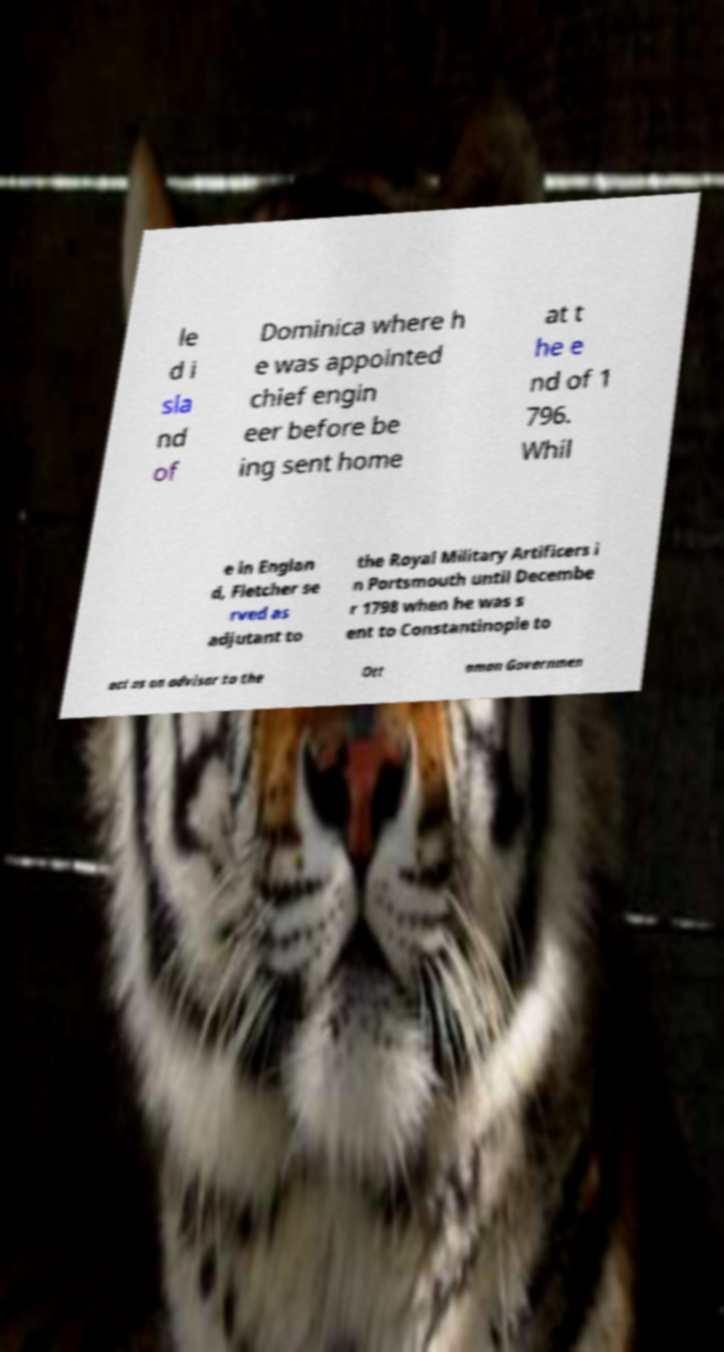Can you accurately transcribe the text from the provided image for me? le d i sla nd of Dominica where h e was appointed chief engin eer before be ing sent home at t he e nd of 1 796. Whil e in Englan d, Fletcher se rved as adjutant to the Royal Military Artificers i n Portsmouth until Decembe r 1798 when he was s ent to Constantinople to act as an advisor to the Ott oman Governmen 